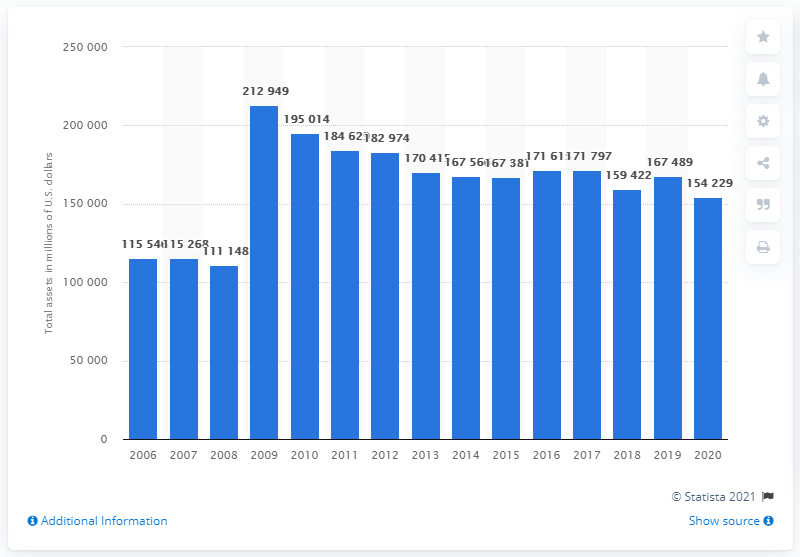Point out several critical features in this image. Pfizer's total assets in dollars in 2020 were 154,229. 